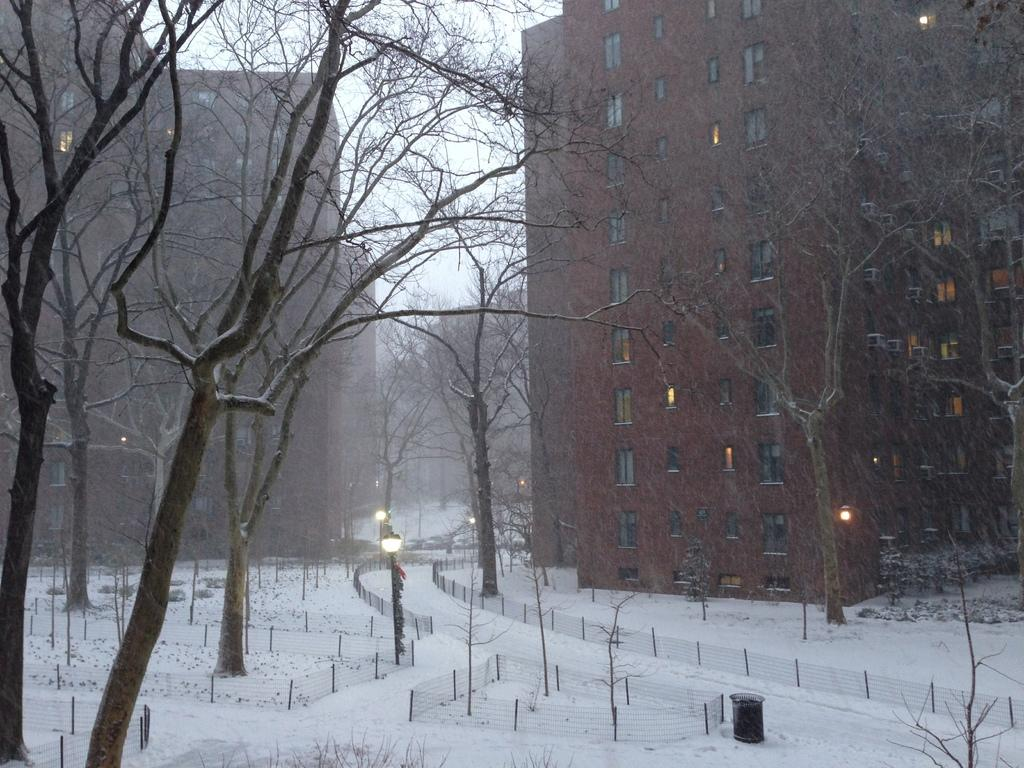What is the main feature of the landscape in the image? There is snow in the image. What type of natural elements can be seen in the image? There are trees in the image. Are there any man-made structures visible in the image? Yes, there are fences in the image. What type of artificial lighting is present in the image? There are lights in the image. What can be seen in the background of the image? In the background, there are lights, buildings, and sky. How does the hose affect the temperature of the snow in the image? There is no hose present in the image, so it cannot affect the temperature of the snow. 